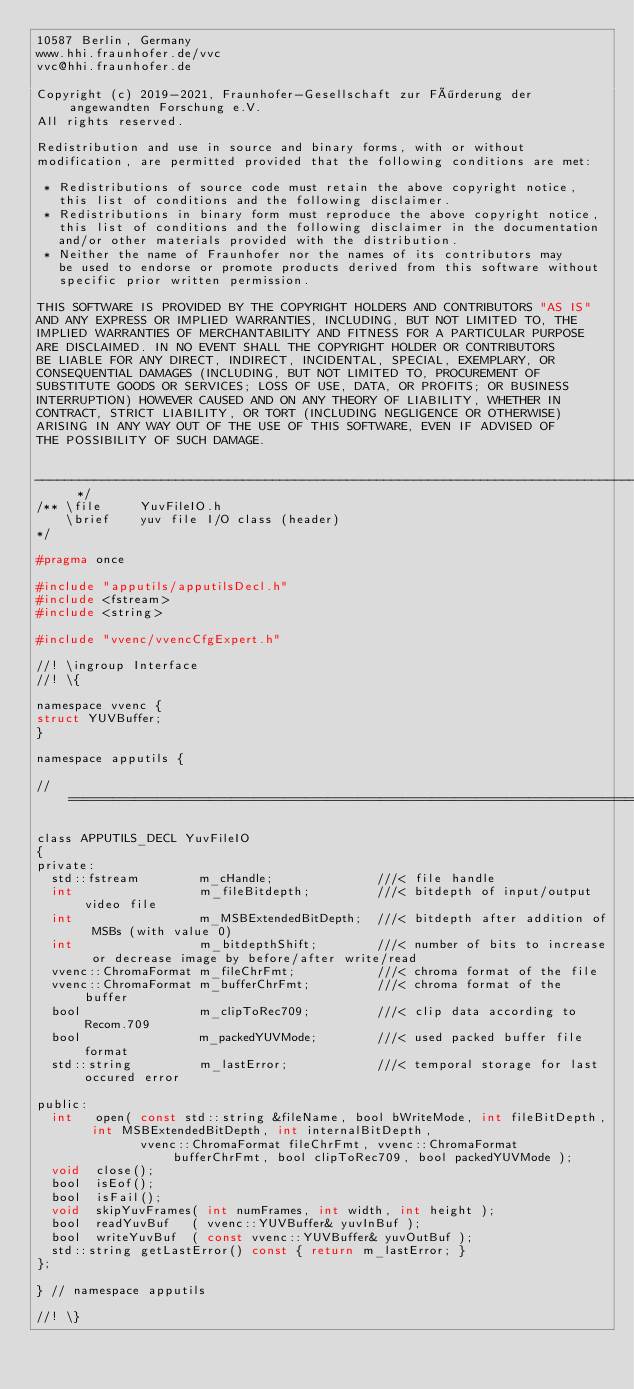Convert code to text. <code><loc_0><loc_0><loc_500><loc_500><_C_>10587 Berlin, Germany
www.hhi.fraunhofer.de/vvc
vvc@hhi.fraunhofer.de

Copyright (c) 2019-2021, Fraunhofer-Gesellschaft zur Förderung der angewandten Forschung e.V.
All rights reserved.

Redistribution and use in source and binary forms, with or without
modification, are permitted provided that the following conditions are met:

 * Redistributions of source code must retain the above copyright notice,
   this list of conditions and the following disclaimer.
 * Redistributions in binary form must reproduce the above copyright notice,
   this list of conditions and the following disclaimer in the documentation
   and/or other materials provided with the distribution.
 * Neither the name of Fraunhofer nor the names of its contributors may
   be used to endorse or promote products derived from this software without
   specific prior written permission.

THIS SOFTWARE IS PROVIDED BY THE COPYRIGHT HOLDERS AND CONTRIBUTORS "AS IS"
AND ANY EXPRESS OR IMPLIED WARRANTIES, INCLUDING, BUT NOT LIMITED TO, THE
IMPLIED WARRANTIES OF MERCHANTABILITY AND FITNESS FOR A PARTICULAR PURPOSE
ARE DISCLAIMED. IN NO EVENT SHALL THE COPYRIGHT HOLDER OR CONTRIBUTORS
BE LIABLE FOR ANY DIRECT, INDIRECT, INCIDENTAL, SPECIAL, EXEMPLARY, OR
CONSEQUENTIAL DAMAGES (INCLUDING, BUT NOT LIMITED TO, PROCUREMENT OF
SUBSTITUTE GOODS OR SERVICES; LOSS OF USE, DATA, OR PROFITS; OR BUSINESS
INTERRUPTION) HOWEVER CAUSED AND ON ANY THEORY OF LIABILITY, WHETHER IN
CONTRACT, STRICT LIABILITY, OR TORT (INCLUDING NEGLIGENCE OR OTHERWISE)
ARISING IN ANY WAY OUT OF THE USE OF THIS SOFTWARE, EVEN IF ADVISED OF
THE POSSIBILITY OF SUCH DAMAGE.


------------------------------------------------------------------------------------------- */
/** \file     YuvFileIO.h
    \brief    yuv file I/O class (header)
*/

#pragma once

#include "apputils/apputilsDecl.h"
#include <fstream>
#include <string>

#include "vvenc/vvencCfgExpert.h"

//! \ingroup Interface
//! \{

namespace vvenc {
struct YUVBuffer;
}

namespace apputils {

// ====================================================================================================================

class APPUTILS_DECL YuvFileIO
{
private:
  std::fstream        m_cHandle;              ///< file handle
  int                 m_fileBitdepth;         ///< bitdepth of input/output video file
  int                 m_MSBExtendedBitDepth;  ///< bitdepth after addition of MSBs (with value 0)
  int                 m_bitdepthShift;        ///< number of bits to increase or decrease image by before/after write/read
  vvenc::ChromaFormat m_fileChrFmt;           ///< chroma format of the file
  vvenc::ChromaFormat m_bufferChrFmt;         ///< chroma format of the buffer
  bool                m_clipToRec709;         ///< clip data according to Recom.709
  bool                m_packedYUVMode;        ///< used packed buffer file format
  std::string         m_lastError;            ///< temporal storage for last occured error 

public:
  int   open( const std::string &fileName, bool bWriteMode, int fileBitDepth, int MSBExtendedBitDepth, int internalBitDepth, 
              vvenc::ChromaFormat fileChrFmt, vvenc::ChromaFormat bufferChrFmt, bool clipToRec709, bool packedYUVMode );
  void  close();
  bool  isEof();
  bool  isFail();
  void  skipYuvFrames( int numFrames, int width, int height );
  bool  readYuvBuf   ( vvenc::YUVBuffer& yuvInBuf );
  bool  writeYuvBuf  ( const vvenc::YUVBuffer& yuvOutBuf );
  std::string getLastError() const { return m_lastError; }   
};

} // namespace apputils

//! \}

</code> 